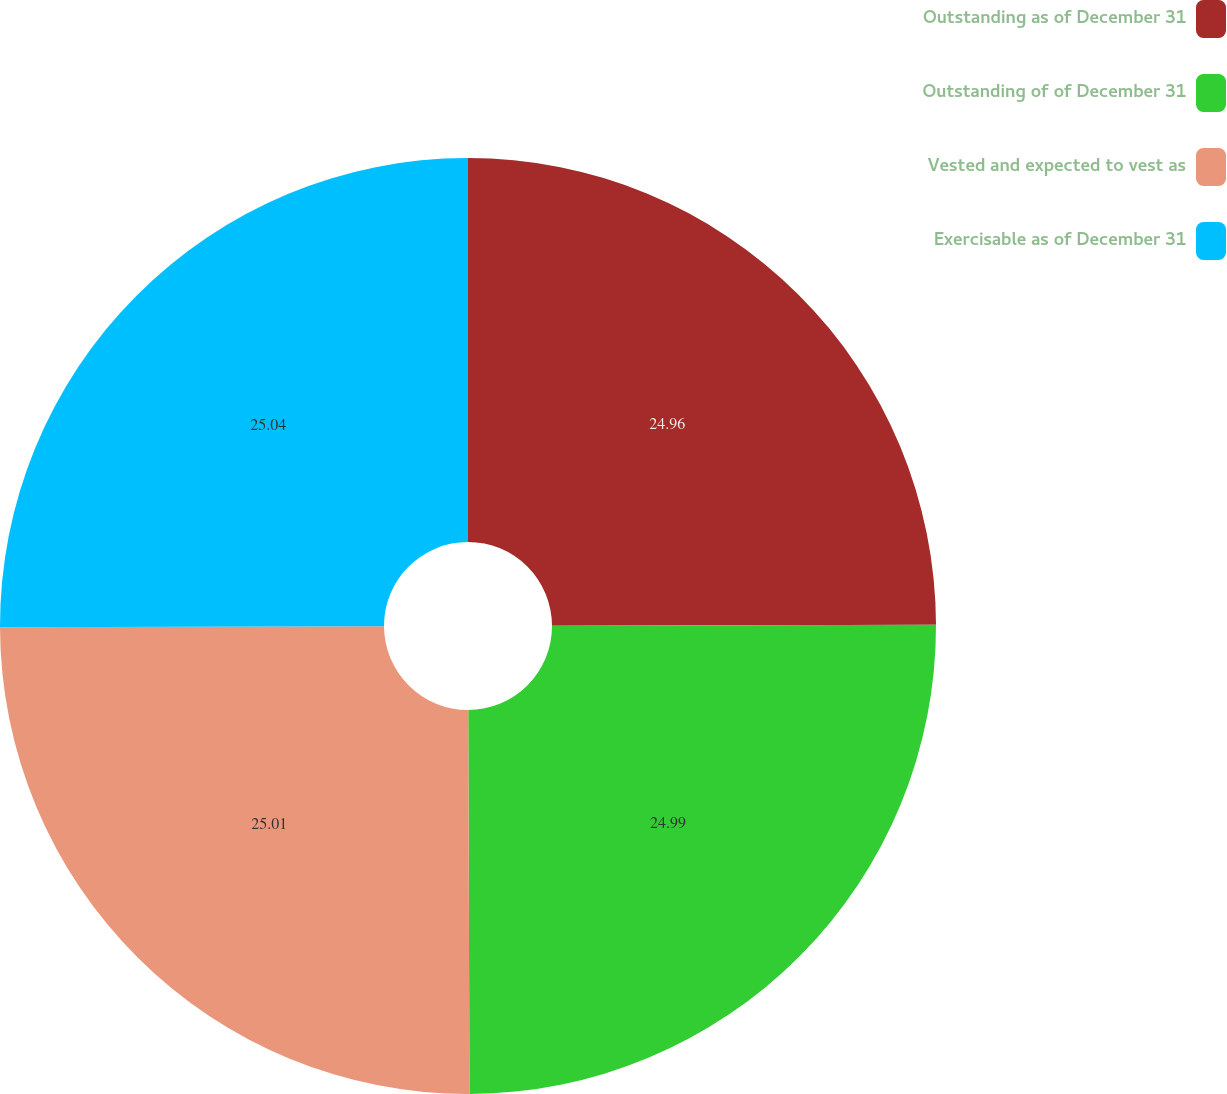<chart> <loc_0><loc_0><loc_500><loc_500><pie_chart><fcel>Outstanding as of December 31<fcel>Outstanding of of December 31<fcel>Vested and expected to vest as<fcel>Exercisable as of December 31<nl><fcel>24.96%<fcel>24.99%<fcel>25.01%<fcel>25.04%<nl></chart> 